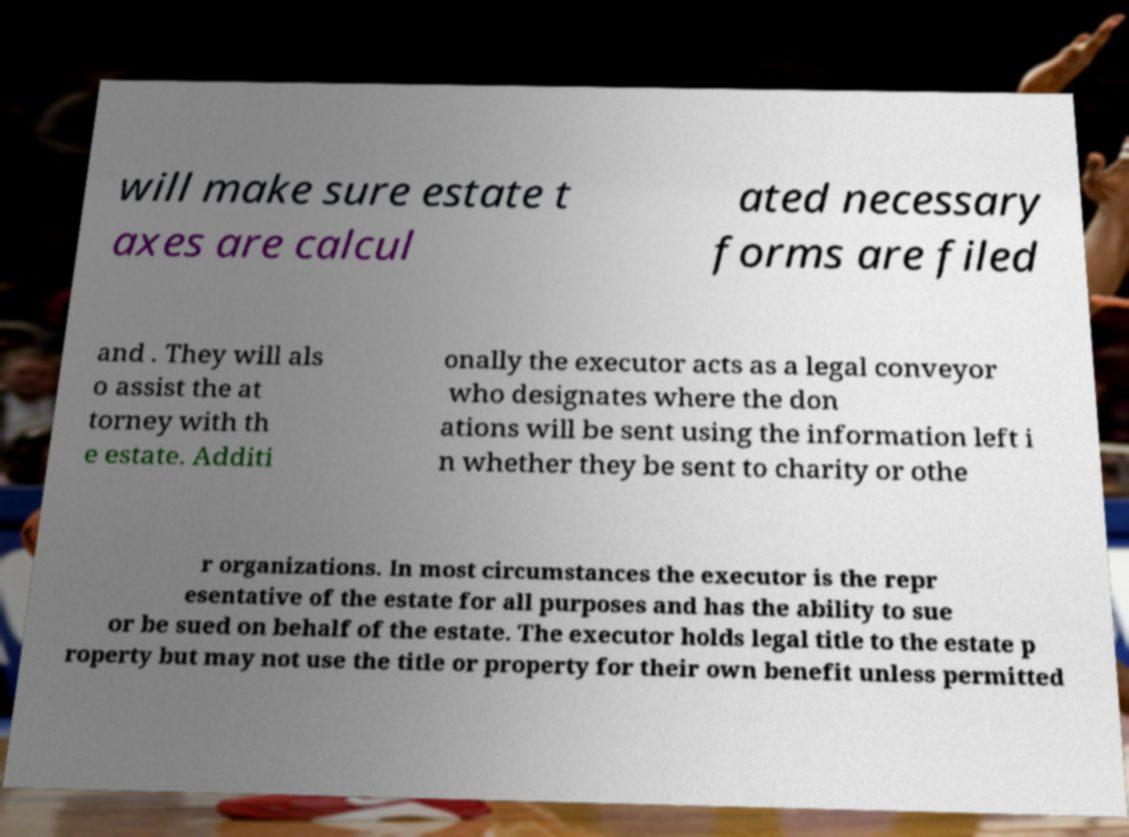What messages or text are displayed in this image? I need them in a readable, typed format. will make sure estate t axes are calcul ated necessary forms are filed and . They will als o assist the at torney with th e estate. Additi onally the executor acts as a legal conveyor who designates where the don ations will be sent using the information left i n whether they be sent to charity or othe r organizations. In most circumstances the executor is the repr esentative of the estate for all purposes and has the ability to sue or be sued on behalf of the estate. The executor holds legal title to the estate p roperty but may not use the title or property for their own benefit unless permitted 